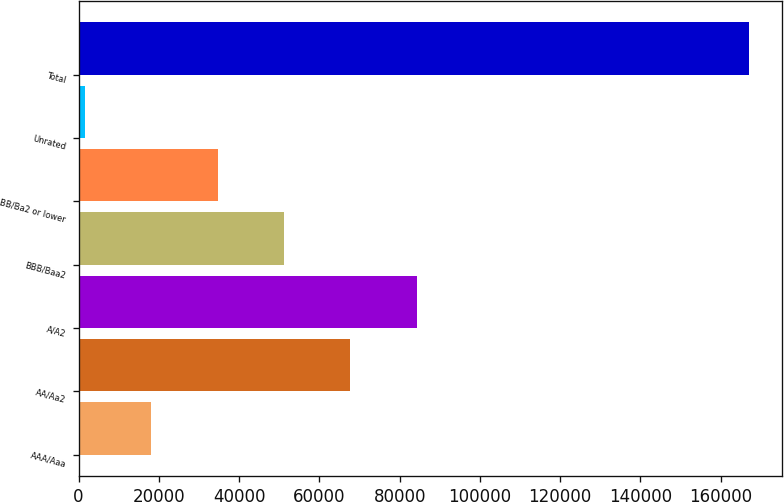Convert chart to OTSL. <chart><loc_0><loc_0><loc_500><loc_500><bar_chart><fcel>AAA/Aaa<fcel>AA/Aa2<fcel>A/A2<fcel>BBB/Baa2<fcel>BB/Ba2 or lower<fcel>Unrated<fcel>Total<nl><fcel>18113.7<fcel>67738.8<fcel>84280.5<fcel>51197.1<fcel>34655.4<fcel>1572<fcel>166989<nl></chart> 